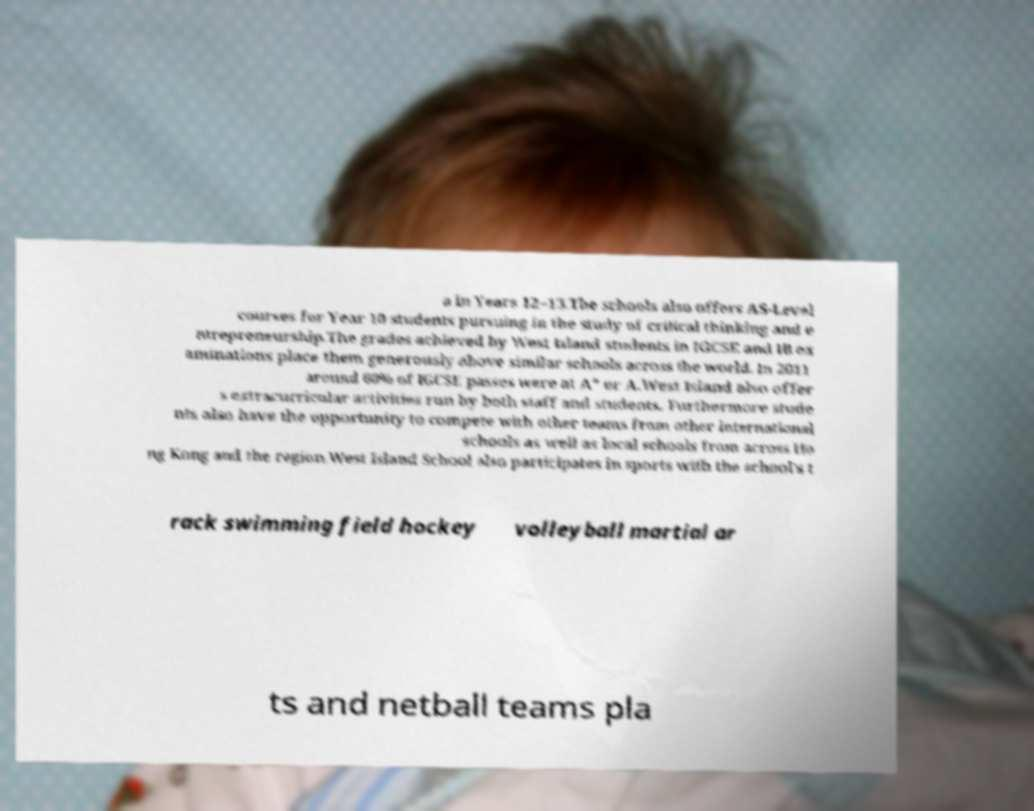Please identify and transcribe the text found in this image. a in Years 12–13.The schools also offers AS-Level courses for Year 10 students pursuing in the study of critical thinking and e ntrepreneurship.The grades achieved by West Island students in IGCSE and IB ex aminations place them generously above similar schools across the world. In 2011 around 60% of IGCSE passes were at A* or A.West Island also offer s extracurricular activities run by both staff and students. Furthermore stude nts also have the opportunity to compete with other teams from other international schools as well as local schools from across Ho ng Kong and the region.West Island School also participates in sports with the school's t rack swimming field hockey volleyball martial ar ts and netball teams pla 